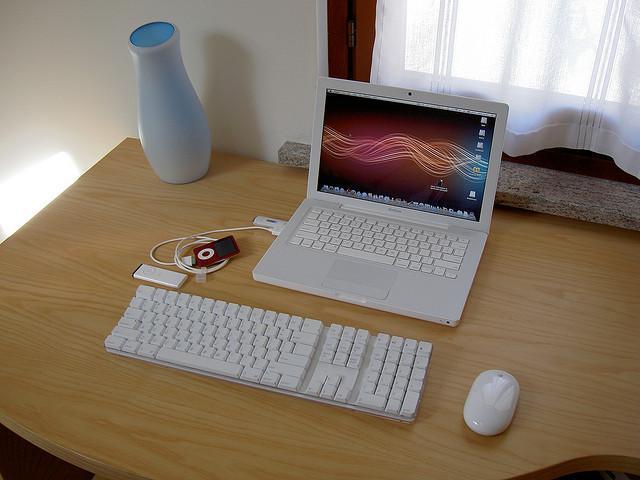How many computer monitors are there?
Give a very brief answer. 1. 